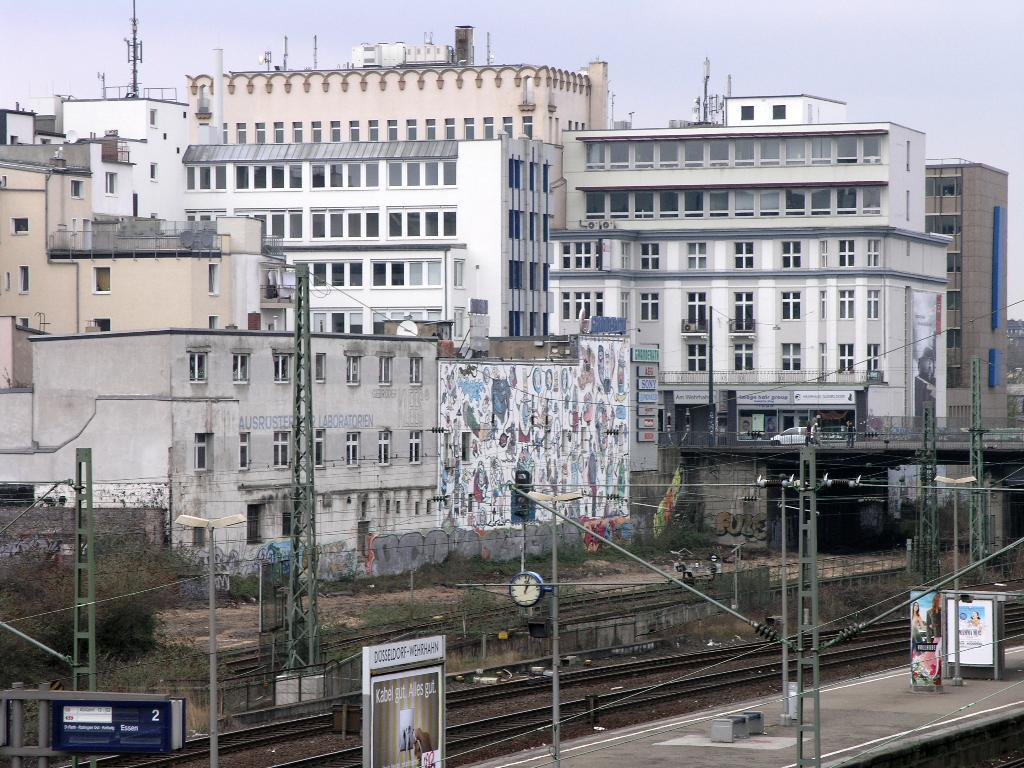What type of structures can be seen in the image? There are buildings in the image. What else can be seen in the image besides the buildings? There are poles, a railway track, and a platform with advertisement boards in the image. What is the condition of the sky in the image? The sky is cloudy in the image. What type of vegetation is visible in the image? There are trees on the side of the image. Where is the crate located in the image? There is no crate present in the image. What type of stove can be seen in the image? There is no stove present in the image. 